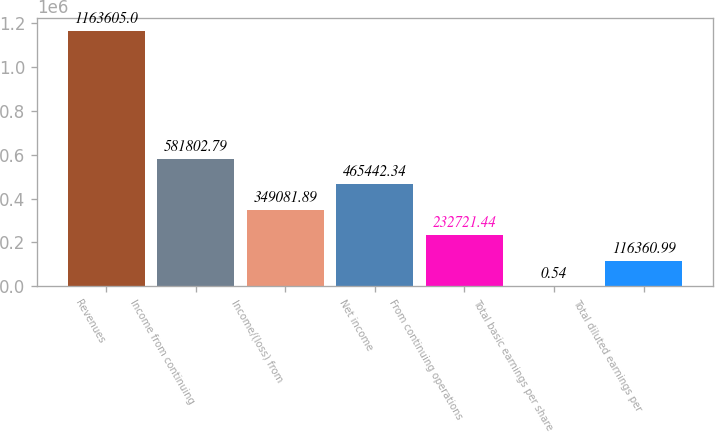<chart> <loc_0><loc_0><loc_500><loc_500><bar_chart><fcel>Revenues<fcel>Income from continuing<fcel>Income/(loss) from<fcel>Net income<fcel>From continuing operations<fcel>Total basic earnings per share<fcel>Total diluted earnings per<nl><fcel>1.1636e+06<fcel>581803<fcel>349082<fcel>465442<fcel>232721<fcel>0.54<fcel>116361<nl></chart> 